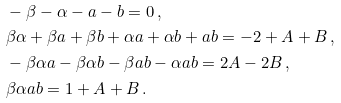Convert formula to latex. <formula><loc_0><loc_0><loc_500><loc_500>& - \beta - \alpha - a - b = 0 \, , \\ & \beta \alpha + \beta a + \beta b + \alpha a + \alpha b + a b = - 2 + A + B \, , \\ & - \beta \alpha a - \beta \alpha b - \beta a b - \alpha a b = 2 A - 2 B \, , \\ & \beta \alpha a b = 1 + A + B \, .</formula> 